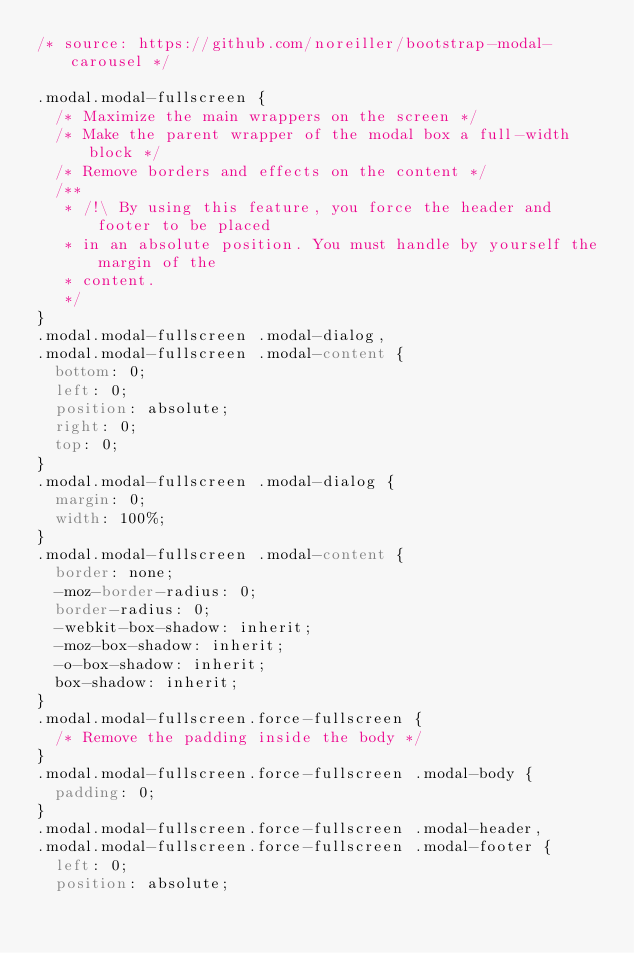Convert code to text. <code><loc_0><loc_0><loc_500><loc_500><_CSS_>/* source: https://github.com/noreiller/bootstrap-modal-carousel */

.modal.modal-fullscreen {
  /* Maximize the main wrappers on the screen */
  /* Make the parent wrapper of the modal box a full-width block */
  /* Remove borders and effects on the content */
  /**
	 * /!\ By using this feature, you force the header and footer to be placed
	 * in an absolute position. You must handle by yourself the margin of the
	 * content.
	 */
}
.modal.modal-fullscreen .modal-dialog,
.modal.modal-fullscreen .modal-content {
  bottom: 0;
  left: 0;
  position: absolute;
  right: 0;
  top: 0;
}
.modal.modal-fullscreen .modal-dialog {
  margin: 0;
  width: 100%;
}
.modal.modal-fullscreen .modal-content {
  border: none;
  -moz-border-radius: 0;
  border-radius: 0;
  -webkit-box-shadow: inherit;
  -moz-box-shadow: inherit;
  -o-box-shadow: inherit;
  box-shadow: inherit;
}
.modal.modal-fullscreen.force-fullscreen {
  /* Remove the padding inside the body */
}
.modal.modal-fullscreen.force-fullscreen .modal-body {
  padding: 0;
}
.modal.modal-fullscreen.force-fullscreen .modal-header,
.modal.modal-fullscreen.force-fullscreen .modal-footer {
  left: 0;
  position: absolute;</code> 